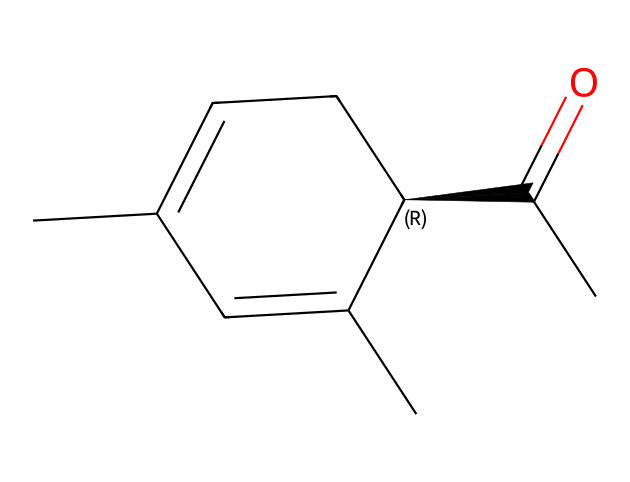What is the molecular formula of this compound? To find the molecular formula, count the number of each type of atom in the chemical structure represented by the SMILES. The structure consists of 10 carbon atoms (C), 12 hydrogen atoms (H), and 1 oxygen atom (O). Therefore, the molecular formula is C10H12O.
Answer: C10H12O How many chiral centers are present in this compound? Examine the structure for any carbon atoms that are bonded to four different substituents. In this SMILES, there is one carbon marked with an '@' symbol, indicating that it is a chiral center. Thus, there is one chiral center.
Answer: one What distinct aromas do the enantiomers of this compound produce? The two enantiomers of carvone produce different aromas. One enantiomer produces a mint scent (spearmint), while the other produces a caraway scent. This is due to the spatial arrangement of atoms around the chiral center affecting how they connect to olfactory receptors.
Answer: mint and caraway Which functional group is present in this molecule? Identify the functional groups by looking at the structure. The SMILES indicates a carbonyl group (C=O) present in the five-membered ring structure, which is characteristic of ketones.
Answer: ketone How does chirality affect the aroma characteristics of carvone? Chirality results in two different spatial arrangements of atoms (enantiomers), leading to each enantiomer interacting differently with olfactory receptors in the nose. This unique interaction explains why each enantiomer has a distinct aroma profile of mint or caraway.
Answer: aromatics differ What is the role of the carbonyl group in this compound? The carbonyl group (C=O) is crucial for determining the properties of the compound. It often influences reactivity and solubility and can also affect the volatility and hence the fragrance characteristics of essential oils, contributing to the aroma.
Answer: chemical properties 